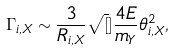<formula> <loc_0><loc_0><loc_500><loc_500>\Gamma _ { i , X } \sim \frac { 3 } { R _ { i , X } } \sqrt { [ } ] { \frac { 4 E } { m _ { Y } } } \theta _ { i , X } ^ { 2 } ,</formula> 